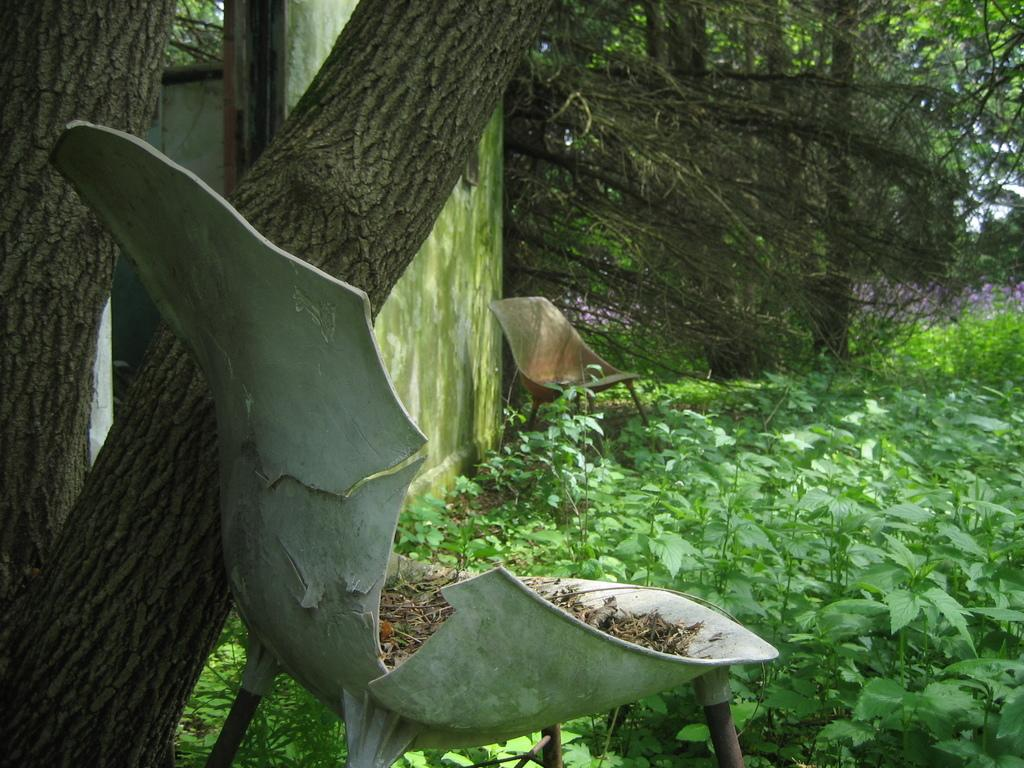What type of vegetation can be seen in the image? There are plants and trees in the image. Where are the plants and trees located? The plants and trees are on the ground in the image. What else can be seen in the image besides plants and trees? There are old chairs present in the image. What is the purpose of the trade between the plants and trees in the image? There is no trade between the plants and trees in the image, as they are not depicted as engaging in any activity or interaction. 